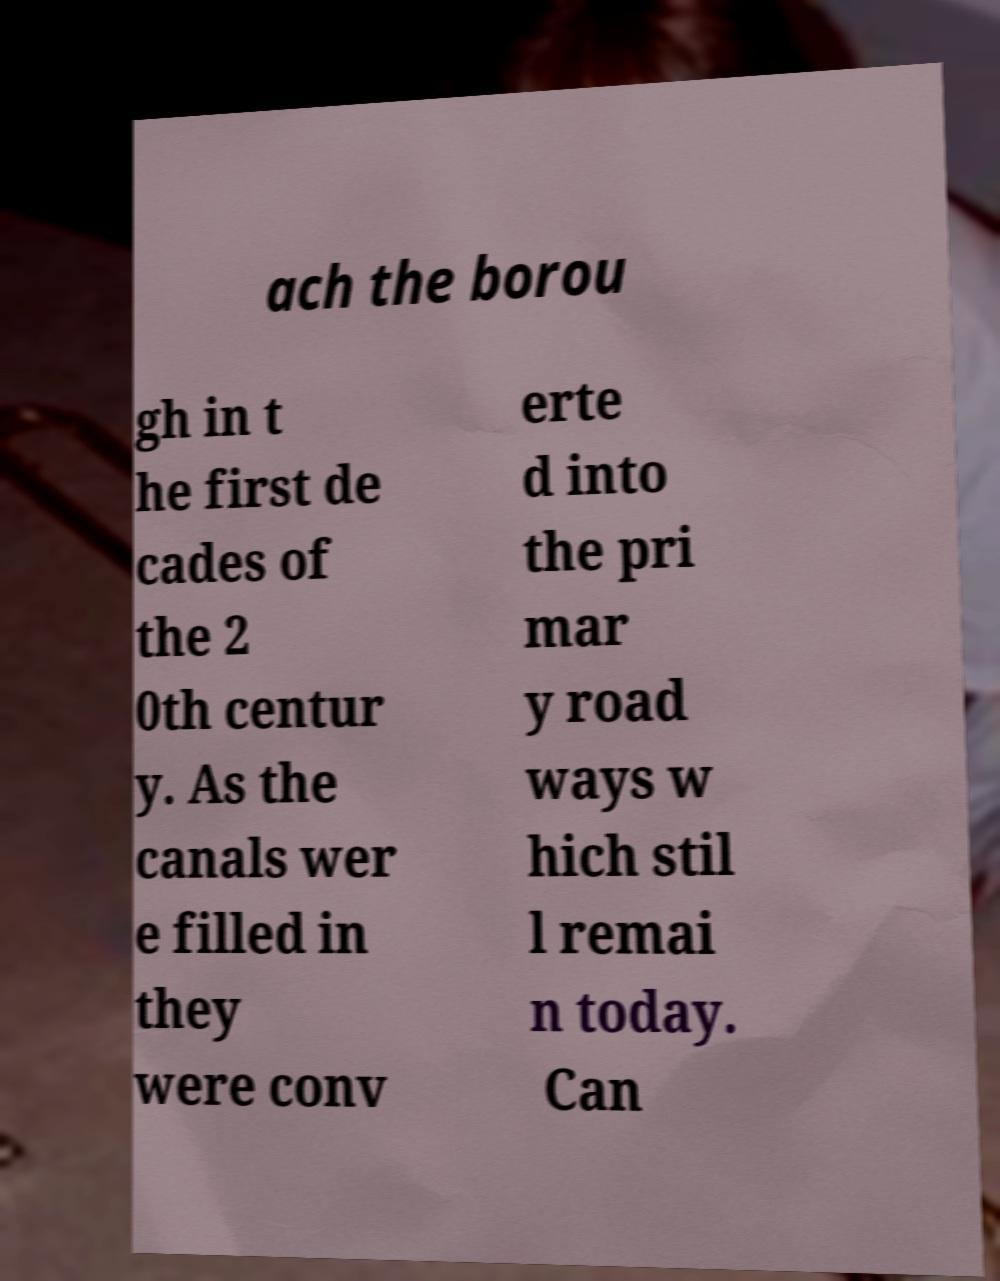I need the written content from this picture converted into text. Can you do that? ach the borou gh in t he first de cades of the 2 0th centur y. As the canals wer e filled in they were conv erte d into the pri mar y road ways w hich stil l remai n today. Can 